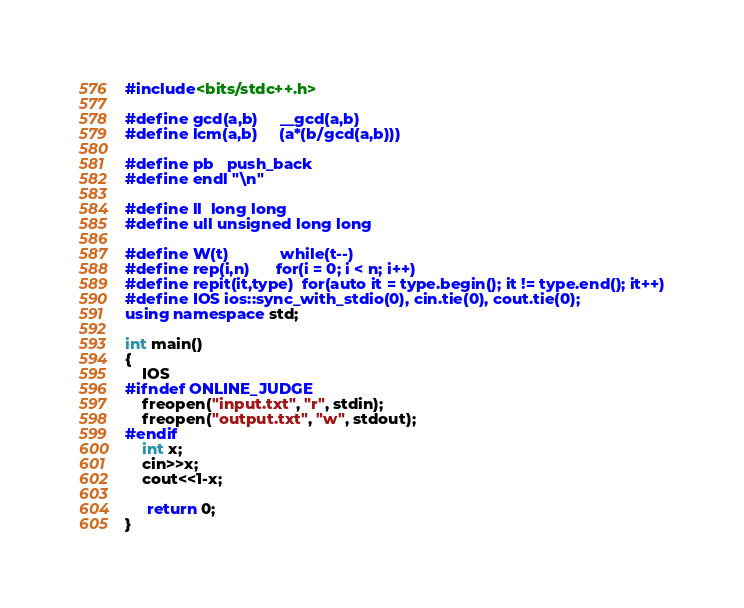<code> <loc_0><loc_0><loc_500><loc_500><_C++_>#include<bits/stdc++.h>

#define gcd(a,b)     __gcd(a,b)
#define lcm(a,b)     (a*(b/gcd(a,b)))

#define pb   push_back
#define endl "\n"

#define ll  long long
#define ull unsigned long long

#define W(t)            while(t--)
#define rep(i,n)      for(i = 0; i < n; i++)
#define repit(it,type)  for(auto it = type.begin(); it != type.end(); it++)
#define IOS ios::sync_with_stdio(0), cin.tie(0), cout.tie(0);
using namespace std;

int main()
{
    IOS
#ifndef ONLINE_JUDGE
    freopen("input.txt", "r", stdin);
    freopen("output.txt", "w", stdout);
#endif
    int x;
    cin>>x;
    cout<<1-x;

     return 0;
}</code> 